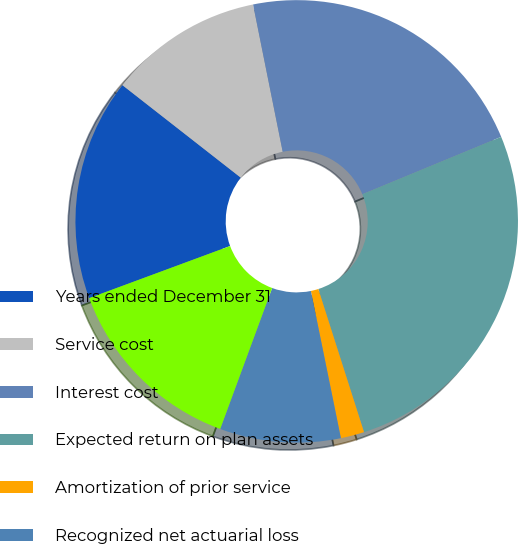Convert chart to OTSL. <chart><loc_0><loc_0><loc_500><loc_500><pie_chart><fcel>Years ended December 31<fcel>Service cost<fcel>Interest cost<fcel>Expected return on plan assets<fcel>Amortization of prior service<fcel>Recognized net actuarial loss<fcel>Net periodic benefit cost<nl><fcel>16.2%<fcel>11.28%<fcel>21.92%<fcel>26.32%<fcel>1.72%<fcel>8.82%<fcel>13.74%<nl></chart> 